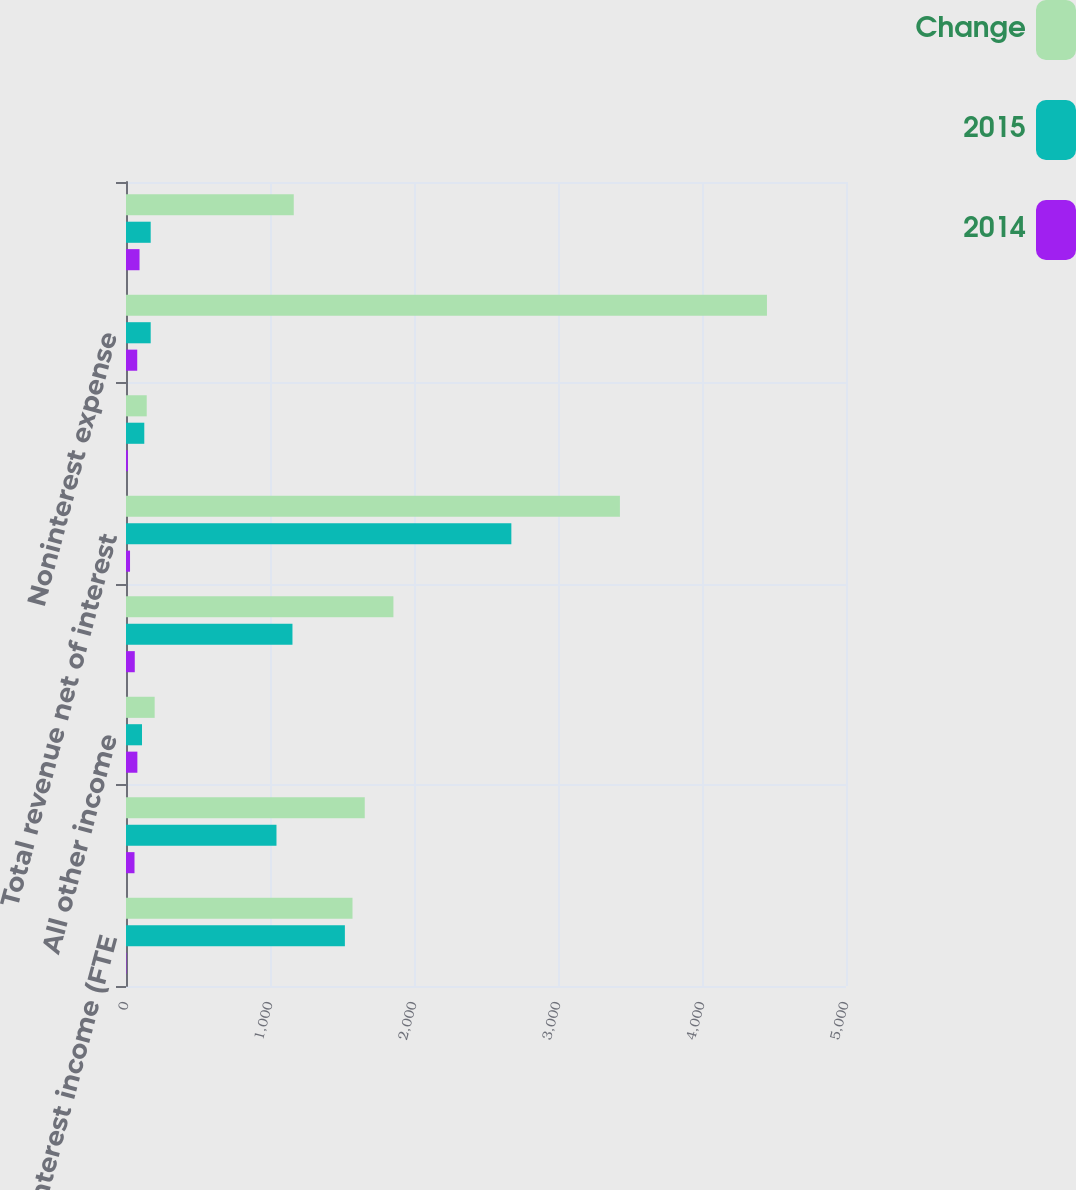Convert chart. <chart><loc_0><loc_0><loc_500><loc_500><stacked_bar_chart><ecel><fcel>Net interest income (FTE<fcel>Mortgage banking income<fcel>All other income<fcel>Total noninterest income<fcel>Total revenue net of interest<fcel>Provision for credit losses<fcel>Noninterest expense<fcel>Loss before income taxes (FTE<nl><fcel>Change<fcel>1573<fcel>1658<fcel>199<fcel>1857<fcel>3430<fcel>144<fcel>4451<fcel>1165<nl><fcel>2015<fcel>1520<fcel>1045<fcel>111<fcel>1156<fcel>2676<fcel>127<fcel>171.5<fcel>171.5<nl><fcel>2014<fcel>3<fcel>59<fcel>79<fcel>61<fcel>28<fcel>13<fcel>78<fcel>94<nl></chart> 